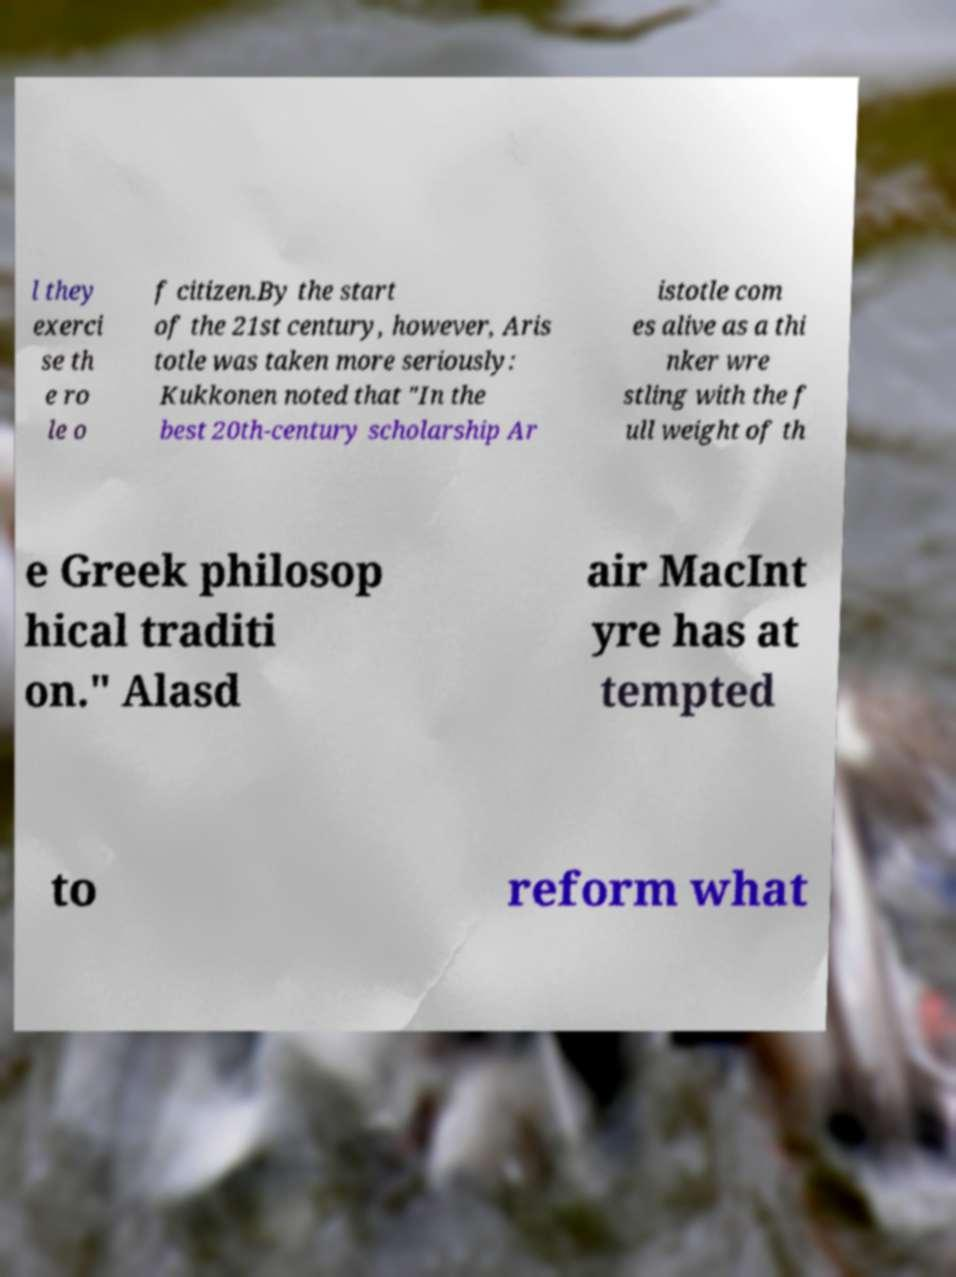I need the written content from this picture converted into text. Can you do that? l they exerci se th e ro le o f citizen.By the start of the 21st century, however, Aris totle was taken more seriously: Kukkonen noted that "In the best 20th-century scholarship Ar istotle com es alive as a thi nker wre stling with the f ull weight of th e Greek philosop hical traditi on." Alasd air MacInt yre has at tempted to reform what 